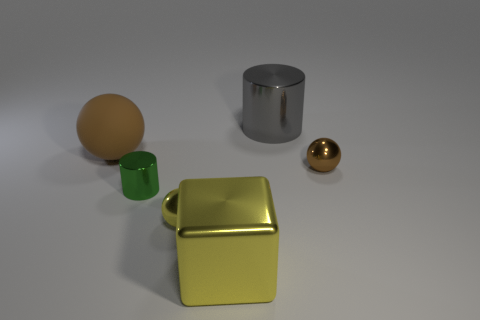Add 4 big spheres. How many objects exist? 10 Subtract all cylinders. How many objects are left? 4 Add 5 large cyan rubber balls. How many large cyan rubber balls exist? 5 Subtract 1 yellow blocks. How many objects are left? 5 Subtract all blocks. Subtract all small green balls. How many objects are left? 5 Add 6 metallic cubes. How many metallic cubes are left? 7 